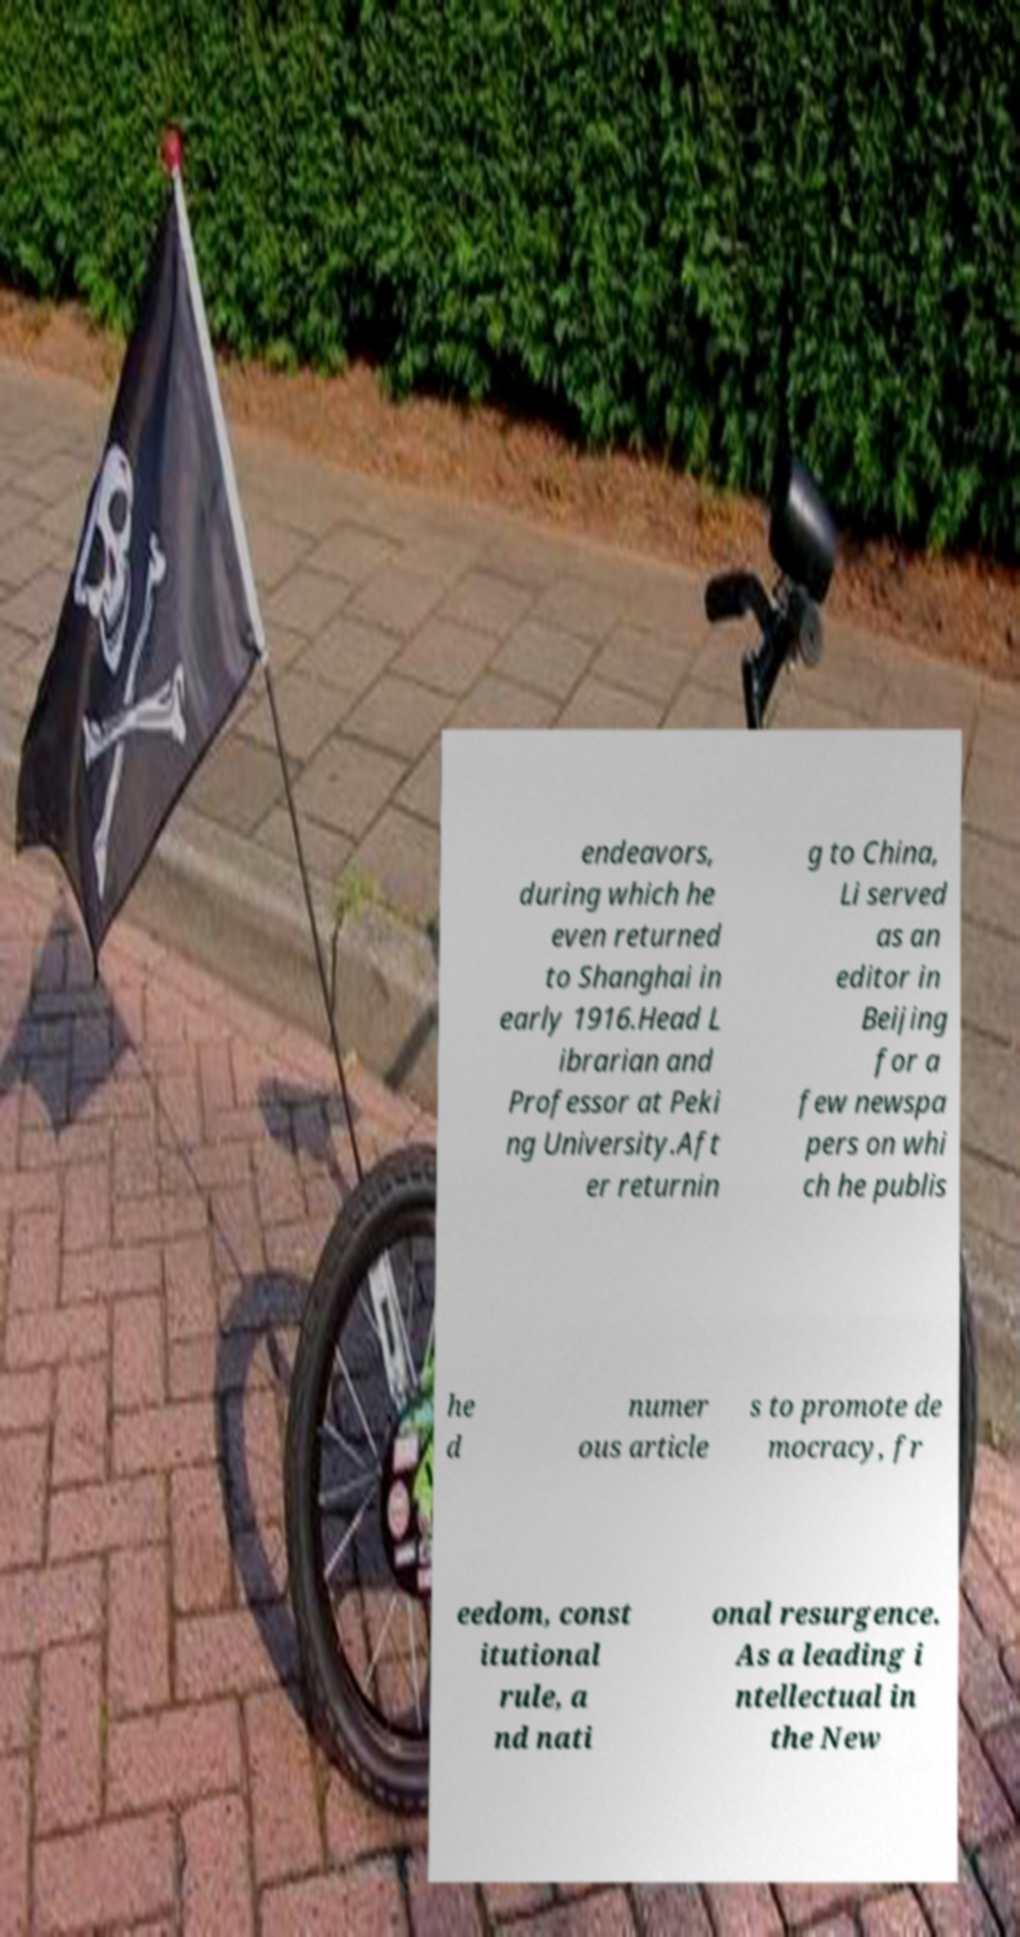Can you read and provide the text displayed in the image?This photo seems to have some interesting text. Can you extract and type it out for me? endeavors, during which he even returned to Shanghai in early 1916.Head L ibrarian and Professor at Peki ng University.Aft er returnin g to China, Li served as an editor in Beijing for a few newspa pers on whi ch he publis he d numer ous article s to promote de mocracy, fr eedom, const itutional rule, a nd nati onal resurgence. As a leading i ntellectual in the New 